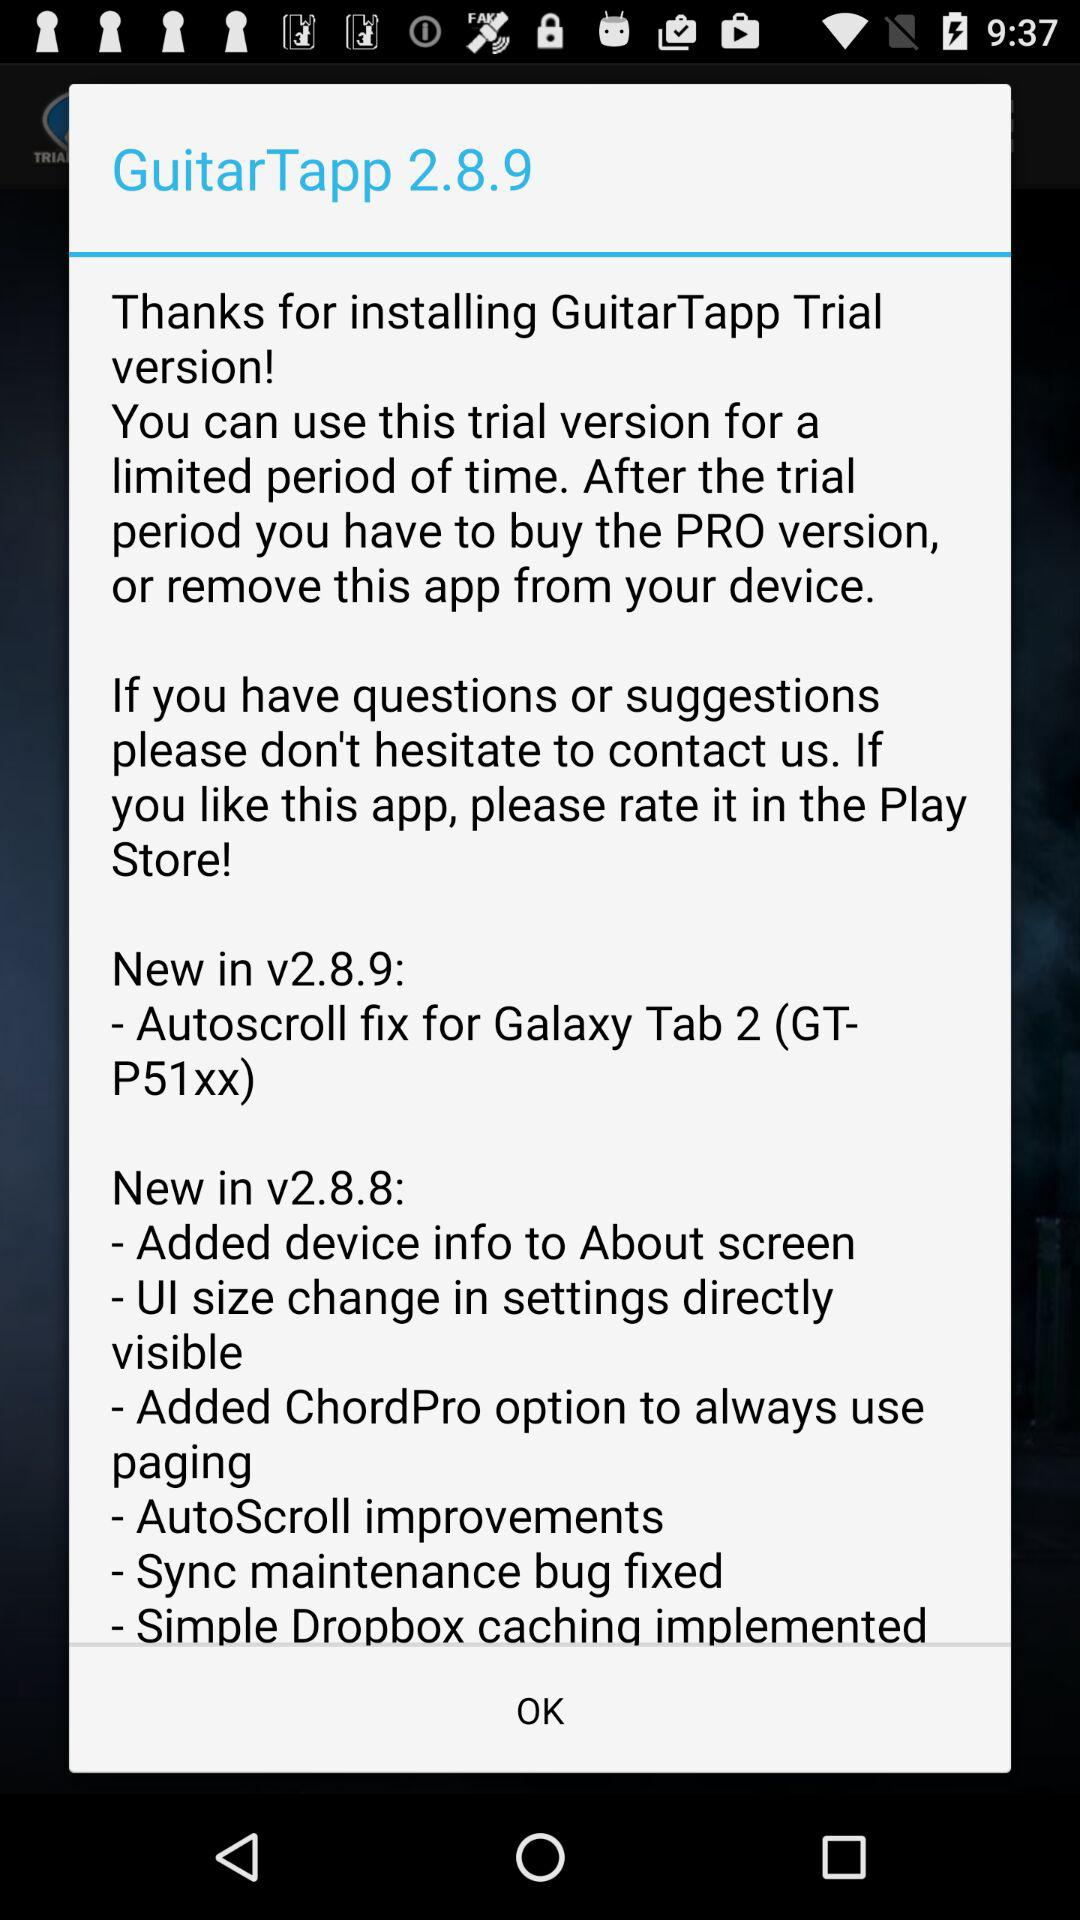What is the version number of the guitar tapp? The version number is 2.8.9. 